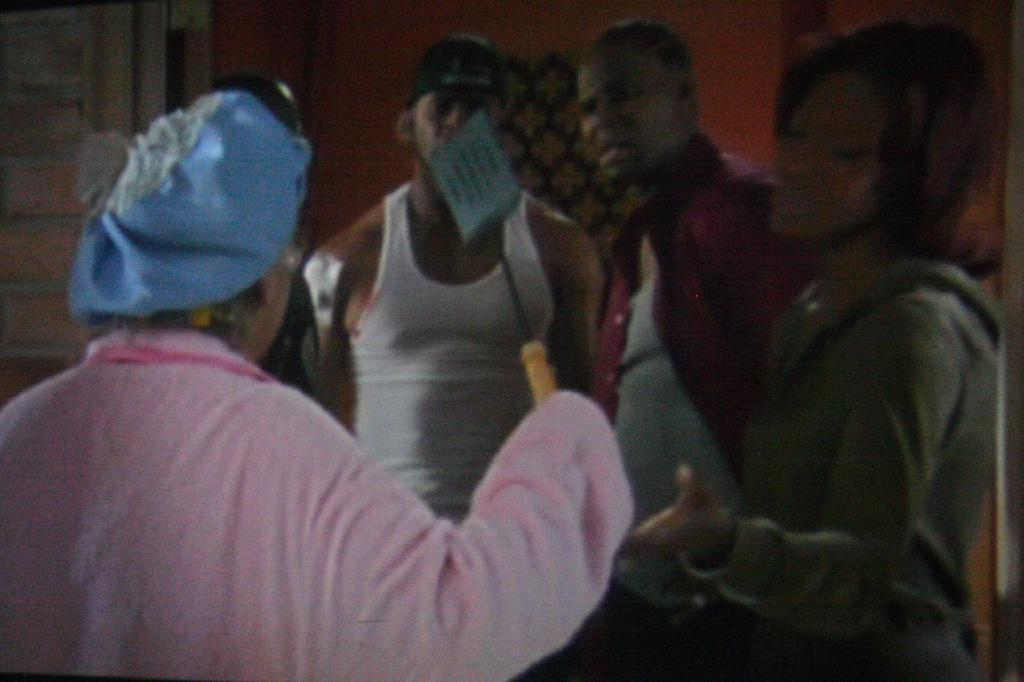How many people are in the image? There is a group of people in the image. Can you describe the position of the woman in the group? A woman is in the front of the group. What is the woman holding in her hand? The woman is holding a spatula spoon in her hand. What type of knot is the woman using to secure the group together in the image? There is no knot present in the image, and the woman is not securing the group together. 